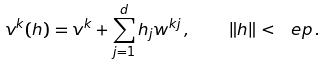Convert formula to latex. <formula><loc_0><loc_0><loc_500><loc_500>v ^ { k } ( h ) = v ^ { k } + \sum _ { j = 1 } ^ { d } h _ { j } w ^ { k j } \, , \quad \| h \| < \ e p \, .</formula> 